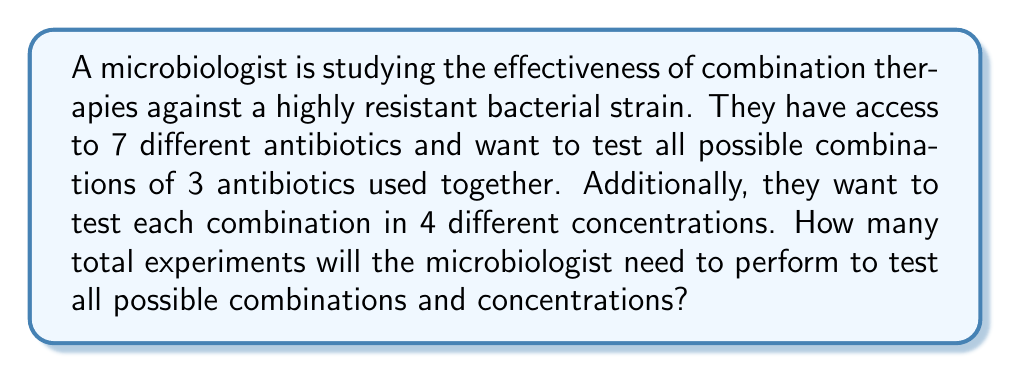Provide a solution to this math problem. Let's approach this problem step-by-step:

1) First, we need to calculate the number of possible combinations of 3 antibiotics from a set of 7. This is a combination problem, denoted as $\binom{7}{3}$ or $C(7,3)$.

   The formula for this combination is:
   
   $$\binom{7}{3} = \frac{7!}{3!(7-3)!} = \frac{7!}{3!4!}$$

2) Let's calculate this:
   
   $$\frac{7 \cdot 6 \cdot 5 \cdot 4!}{(3 \cdot 2 \cdot 1) \cdot 4!} = \frac{210}{6} = 35$$

3) So there are 35 possible combinations of 3 antibiotics from the set of 7.

4) Now, each of these 35 combinations needs to be tested in 4 different concentrations. This means we need to multiply our number of combinations by 4:

   $$35 \cdot 4 = 140$$

Therefore, the microbiologist will need to perform 140 experiments to test all possible combinations of 3 antibiotics in 4 different concentrations.
Answer: 140 experiments 